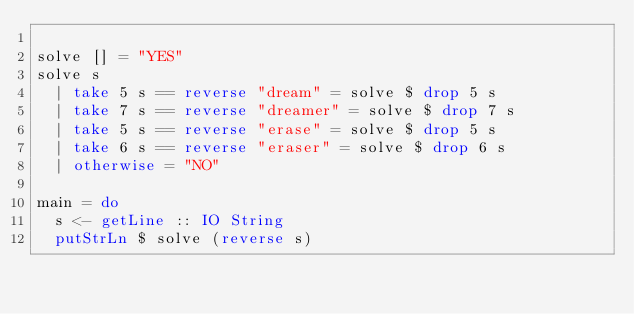Convert code to text. <code><loc_0><loc_0><loc_500><loc_500><_Haskell_>
solve [] = "YES"
solve s
  | take 5 s == reverse "dream" = solve $ drop 5 s
  | take 7 s == reverse "dreamer" = solve $ drop 7 s
  | take 5 s == reverse "erase" = solve $ drop 5 s
  | take 6 s == reverse "eraser" = solve $ drop 6 s
  | otherwise = "NO"

main = do
  s <- getLine :: IO String
  putStrLn $ solve (reverse s)
</code> 